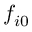<formula> <loc_0><loc_0><loc_500><loc_500>f _ { i 0 }</formula> 